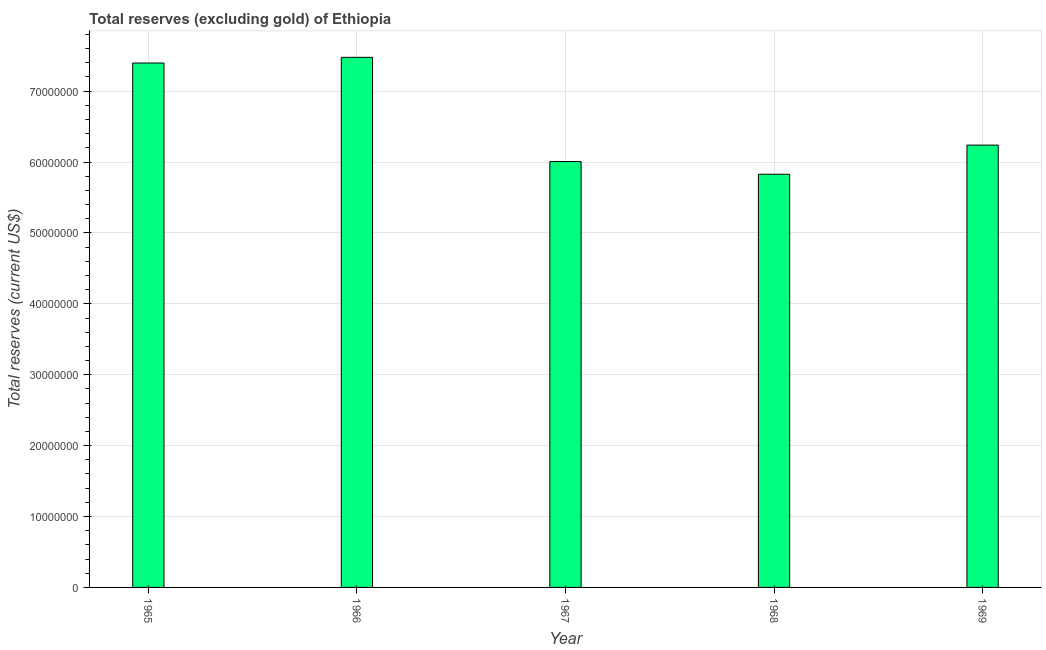What is the title of the graph?
Your response must be concise. Total reserves (excluding gold) of Ethiopia. What is the label or title of the X-axis?
Offer a very short reply. Year. What is the label or title of the Y-axis?
Offer a terse response. Total reserves (current US$). What is the total reserves (excluding gold) in 1965?
Your answer should be very brief. 7.40e+07. Across all years, what is the maximum total reserves (excluding gold)?
Your response must be concise. 7.48e+07. Across all years, what is the minimum total reserves (excluding gold)?
Your response must be concise. 5.83e+07. In which year was the total reserves (excluding gold) maximum?
Your response must be concise. 1966. In which year was the total reserves (excluding gold) minimum?
Give a very brief answer. 1968. What is the sum of the total reserves (excluding gold)?
Ensure brevity in your answer.  3.29e+08. What is the difference between the total reserves (excluding gold) in 1965 and 1968?
Make the answer very short. 1.57e+07. What is the average total reserves (excluding gold) per year?
Offer a very short reply. 6.59e+07. What is the median total reserves (excluding gold)?
Provide a short and direct response. 6.24e+07. In how many years, is the total reserves (excluding gold) greater than 72000000 US$?
Give a very brief answer. 2. Do a majority of the years between 1965 and 1966 (inclusive) have total reserves (excluding gold) greater than 42000000 US$?
Make the answer very short. Yes. What is the ratio of the total reserves (excluding gold) in 1966 to that in 1967?
Ensure brevity in your answer.  1.25. Is the total reserves (excluding gold) in 1966 less than that in 1969?
Your answer should be compact. No. Is the difference between the total reserves (excluding gold) in 1965 and 1966 greater than the difference between any two years?
Give a very brief answer. No. What is the difference between the highest and the second highest total reserves (excluding gold)?
Your response must be concise. 8.00e+05. Is the sum of the total reserves (excluding gold) in 1965 and 1969 greater than the maximum total reserves (excluding gold) across all years?
Your answer should be very brief. Yes. What is the difference between the highest and the lowest total reserves (excluding gold)?
Offer a very short reply. 1.65e+07. How many bars are there?
Your answer should be very brief. 5. How many years are there in the graph?
Keep it short and to the point. 5. What is the difference between two consecutive major ticks on the Y-axis?
Make the answer very short. 1.00e+07. What is the Total reserves (current US$) in 1965?
Provide a succinct answer. 7.40e+07. What is the Total reserves (current US$) of 1966?
Offer a terse response. 7.48e+07. What is the Total reserves (current US$) in 1967?
Offer a very short reply. 6.01e+07. What is the Total reserves (current US$) in 1968?
Ensure brevity in your answer.  5.83e+07. What is the Total reserves (current US$) of 1969?
Ensure brevity in your answer.  6.24e+07. What is the difference between the Total reserves (current US$) in 1965 and 1966?
Offer a very short reply. -8.00e+05. What is the difference between the Total reserves (current US$) in 1965 and 1967?
Ensure brevity in your answer.  1.39e+07. What is the difference between the Total reserves (current US$) in 1965 and 1968?
Offer a terse response. 1.57e+07. What is the difference between the Total reserves (current US$) in 1965 and 1969?
Keep it short and to the point. 1.16e+07. What is the difference between the Total reserves (current US$) in 1966 and 1967?
Provide a short and direct response. 1.47e+07. What is the difference between the Total reserves (current US$) in 1966 and 1968?
Your answer should be very brief. 1.65e+07. What is the difference between the Total reserves (current US$) in 1966 and 1969?
Provide a succinct answer. 1.24e+07. What is the difference between the Total reserves (current US$) in 1967 and 1968?
Your answer should be very brief. 1.79e+06. What is the difference between the Total reserves (current US$) in 1967 and 1969?
Your response must be concise. -2.32e+06. What is the difference between the Total reserves (current US$) in 1968 and 1969?
Make the answer very short. -4.11e+06. What is the ratio of the Total reserves (current US$) in 1965 to that in 1966?
Provide a succinct answer. 0.99. What is the ratio of the Total reserves (current US$) in 1965 to that in 1967?
Ensure brevity in your answer.  1.23. What is the ratio of the Total reserves (current US$) in 1965 to that in 1968?
Your answer should be compact. 1.27. What is the ratio of the Total reserves (current US$) in 1965 to that in 1969?
Ensure brevity in your answer.  1.19. What is the ratio of the Total reserves (current US$) in 1966 to that in 1967?
Ensure brevity in your answer.  1.25. What is the ratio of the Total reserves (current US$) in 1966 to that in 1968?
Give a very brief answer. 1.28. What is the ratio of the Total reserves (current US$) in 1966 to that in 1969?
Offer a terse response. 1.2. What is the ratio of the Total reserves (current US$) in 1967 to that in 1968?
Ensure brevity in your answer.  1.03. What is the ratio of the Total reserves (current US$) in 1967 to that in 1969?
Offer a very short reply. 0.96. What is the ratio of the Total reserves (current US$) in 1968 to that in 1969?
Provide a short and direct response. 0.93. 